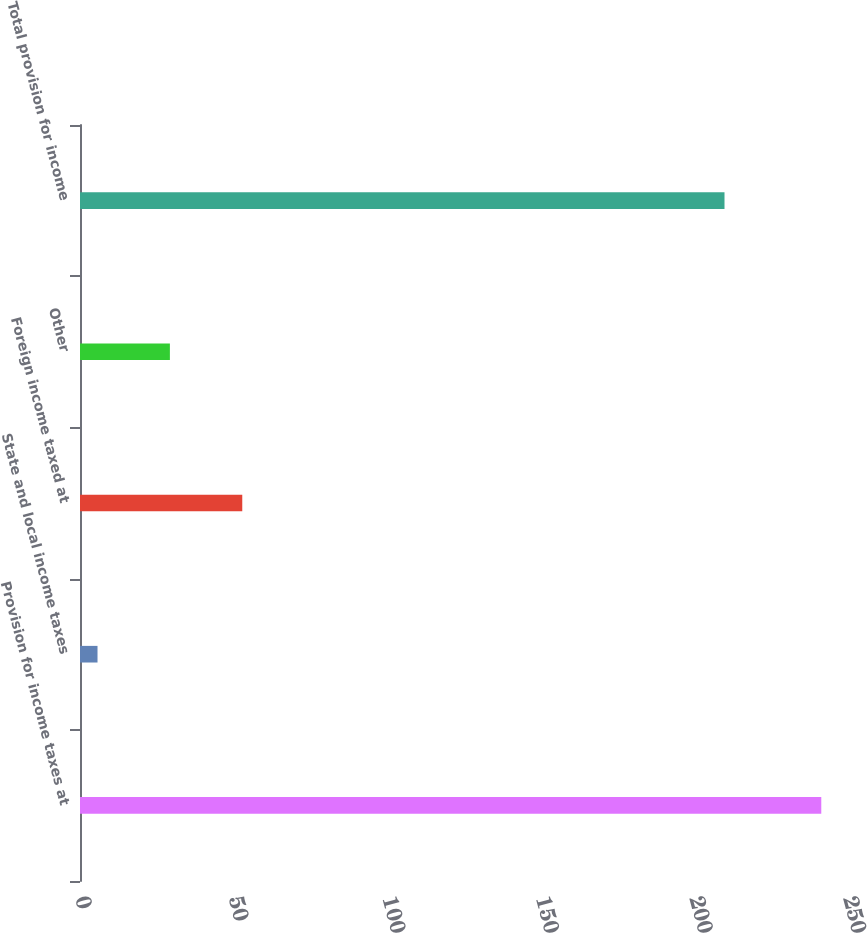Convert chart. <chart><loc_0><loc_0><loc_500><loc_500><bar_chart><fcel>Provision for income taxes at<fcel>State and local income taxes<fcel>Foreign income taxed at<fcel>Other<fcel>Total provision for income<nl><fcel>241.3<fcel>5.7<fcel>52.82<fcel>29.26<fcel>209.8<nl></chart> 